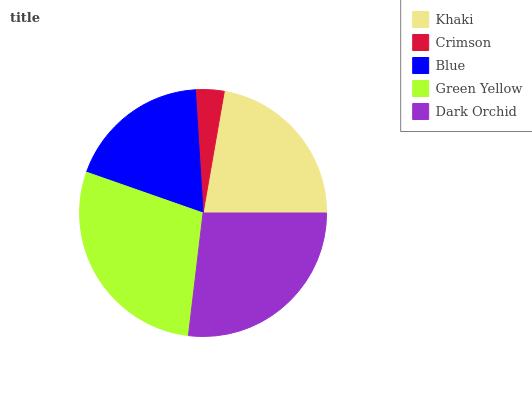Is Crimson the minimum?
Answer yes or no. Yes. Is Green Yellow the maximum?
Answer yes or no. Yes. Is Blue the minimum?
Answer yes or no. No. Is Blue the maximum?
Answer yes or no. No. Is Blue greater than Crimson?
Answer yes or no. Yes. Is Crimson less than Blue?
Answer yes or no. Yes. Is Crimson greater than Blue?
Answer yes or no. No. Is Blue less than Crimson?
Answer yes or no. No. Is Khaki the high median?
Answer yes or no. Yes. Is Khaki the low median?
Answer yes or no. Yes. Is Green Yellow the high median?
Answer yes or no. No. Is Dark Orchid the low median?
Answer yes or no. No. 